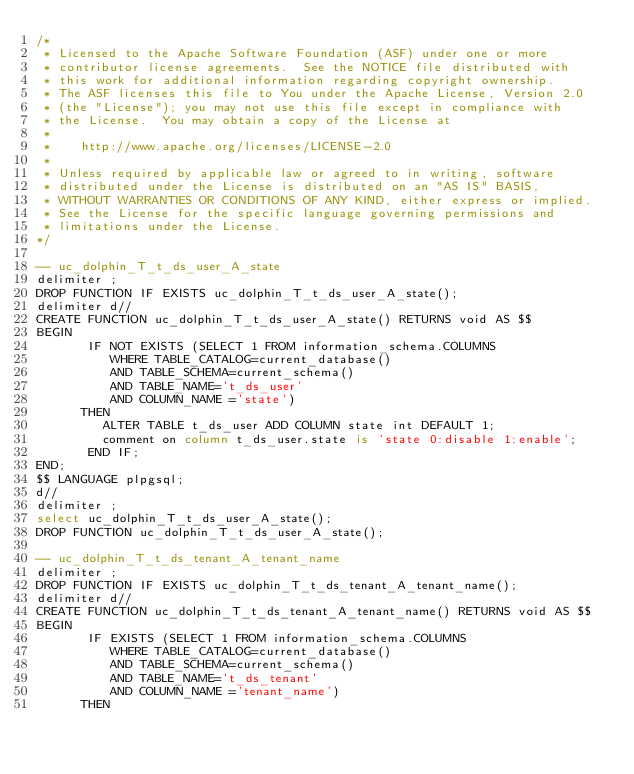Convert code to text. <code><loc_0><loc_0><loc_500><loc_500><_SQL_>/*
 * Licensed to the Apache Software Foundation (ASF) under one or more
 * contributor license agreements.  See the NOTICE file distributed with
 * this work for additional information regarding copyright ownership.
 * The ASF licenses this file to You under the Apache License, Version 2.0
 * (the "License"); you may not use this file except in compliance with
 * the License.  You may obtain a copy of the License at
 *
 *    http://www.apache.org/licenses/LICENSE-2.0
 *
 * Unless required by applicable law or agreed to in writing, software
 * distributed under the License is distributed on an "AS IS" BASIS,
 * WITHOUT WARRANTIES OR CONDITIONS OF ANY KIND, either express or implied.
 * See the License for the specific language governing permissions and
 * limitations under the License.
*/

-- uc_dolphin_T_t_ds_user_A_state
delimiter ;
DROP FUNCTION IF EXISTS uc_dolphin_T_t_ds_user_A_state();
delimiter d//
CREATE FUNCTION uc_dolphin_T_t_ds_user_A_state() RETURNS void AS $$
BEGIN
       IF NOT EXISTS (SELECT 1 FROM information_schema.COLUMNS
          WHERE TABLE_CATALOG=current_database()
          AND TABLE_SCHEMA=current_schema()
          AND TABLE_NAME='t_ds_user'
          AND COLUMN_NAME ='state')
      THEN
         ALTER TABLE t_ds_user ADD COLUMN state int DEFAULT 1;
         comment on column t_ds_user.state is 'state 0:disable 1:enable';
       END IF;
END;
$$ LANGUAGE plpgsql;
d//
delimiter ;
select uc_dolphin_T_t_ds_user_A_state();
DROP FUNCTION uc_dolphin_T_t_ds_user_A_state();

-- uc_dolphin_T_t_ds_tenant_A_tenant_name
delimiter ;
DROP FUNCTION IF EXISTS uc_dolphin_T_t_ds_tenant_A_tenant_name();
delimiter d//
CREATE FUNCTION uc_dolphin_T_t_ds_tenant_A_tenant_name() RETURNS void AS $$
BEGIN
       IF EXISTS (SELECT 1 FROM information_schema.COLUMNS
          WHERE TABLE_CATALOG=current_database()
          AND TABLE_SCHEMA=current_schema()
          AND TABLE_NAME='t_ds_tenant'
          AND COLUMN_NAME ='tenant_name')
      THEN</code> 